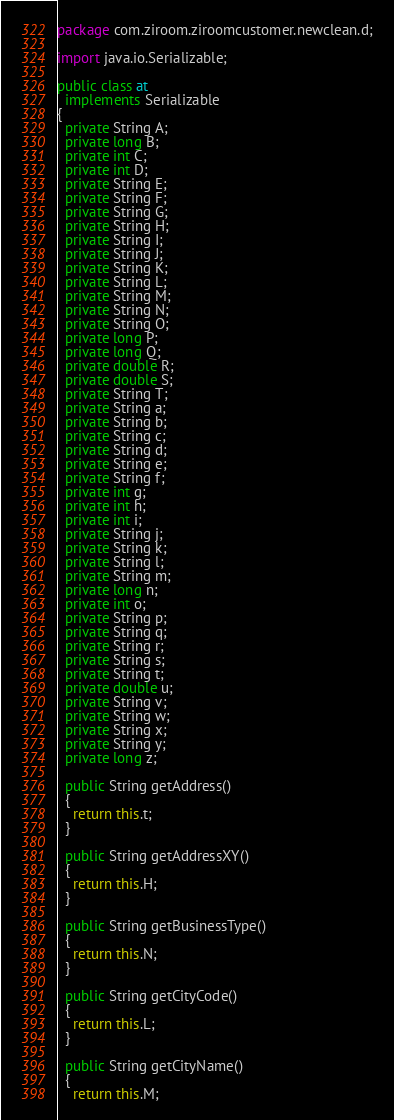<code> <loc_0><loc_0><loc_500><loc_500><_Java_>package com.ziroom.ziroomcustomer.newclean.d;

import java.io.Serializable;

public class at
  implements Serializable
{
  private String A;
  private long B;
  private int C;
  private int D;
  private String E;
  private String F;
  private String G;
  private String H;
  private String I;
  private String J;
  private String K;
  private String L;
  private String M;
  private String N;
  private String O;
  private long P;
  private long Q;
  private double R;
  private double S;
  private String T;
  private String a;
  private String b;
  private String c;
  private String d;
  private String e;
  private String f;
  private int g;
  private int h;
  private int i;
  private String j;
  private String k;
  private String l;
  private String m;
  private long n;
  private int o;
  private String p;
  private String q;
  private String r;
  private String s;
  private String t;
  private double u;
  private String v;
  private String w;
  private String x;
  private String y;
  private long z;
  
  public String getAddress()
  {
    return this.t;
  }
  
  public String getAddressXY()
  {
    return this.H;
  }
  
  public String getBusinessType()
  {
    return this.N;
  }
  
  public String getCityCode()
  {
    return this.L;
  }
  
  public String getCityName()
  {
    return this.M;</code> 